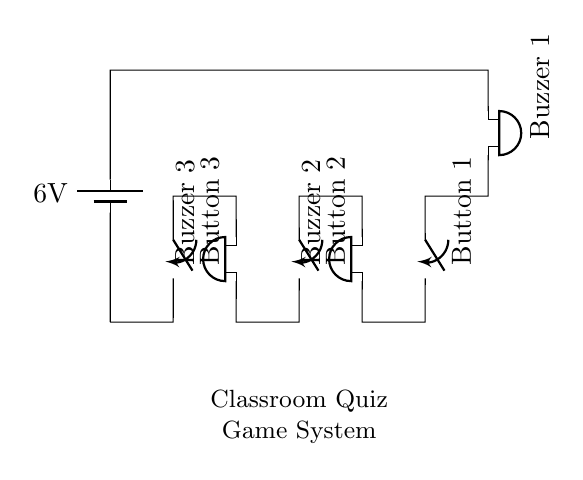What is the total voltage of the circuit? The circuit shows a battery labeled with a voltage of 6 volts. This represents the total voltage provided by the battery to the entire circuit.
Answer: 6 volts How many buzzers are in this circuit? The circuit diagram includes three buzzers, labeled as Buzzer 1, Buzzer 2, and Buzzer 3. Each buzzer is a component of the series circuit.
Answer: 3 What would happen if Button 1 is pressed? Pressing Button 1 closes the switch, allowing current to flow through Buzzer 1, which will activate and produce sound. In a series circuit, this affects only Buzzer 1 because it is connected directly to that button.
Answer: Buzzer 1 sounds If all buttons are pressed, how will the buzzers behave? Since the circuit is a series circuit, pressing all buttons will allow current to flow through all three buzzers simultaneously, causing all of them to sound. Thus, all buzzers would activate.
Answer: All buzzers sound Which component controls the activation of Buzzer 2? Buzzer 2 is directly controlled by Button 2. When Button 2 is pressed, it completes the circuit path for Buzzer 2, allowing it to activate.
Answer: Button 2 What type of circuit is this? This is a series circuit, as all components (batteries, buzzers, switches) are connected end-to-end in a single path for current to flow. If one component fails or is turned off, the entire circuit stops functioning.
Answer: Series circuit 